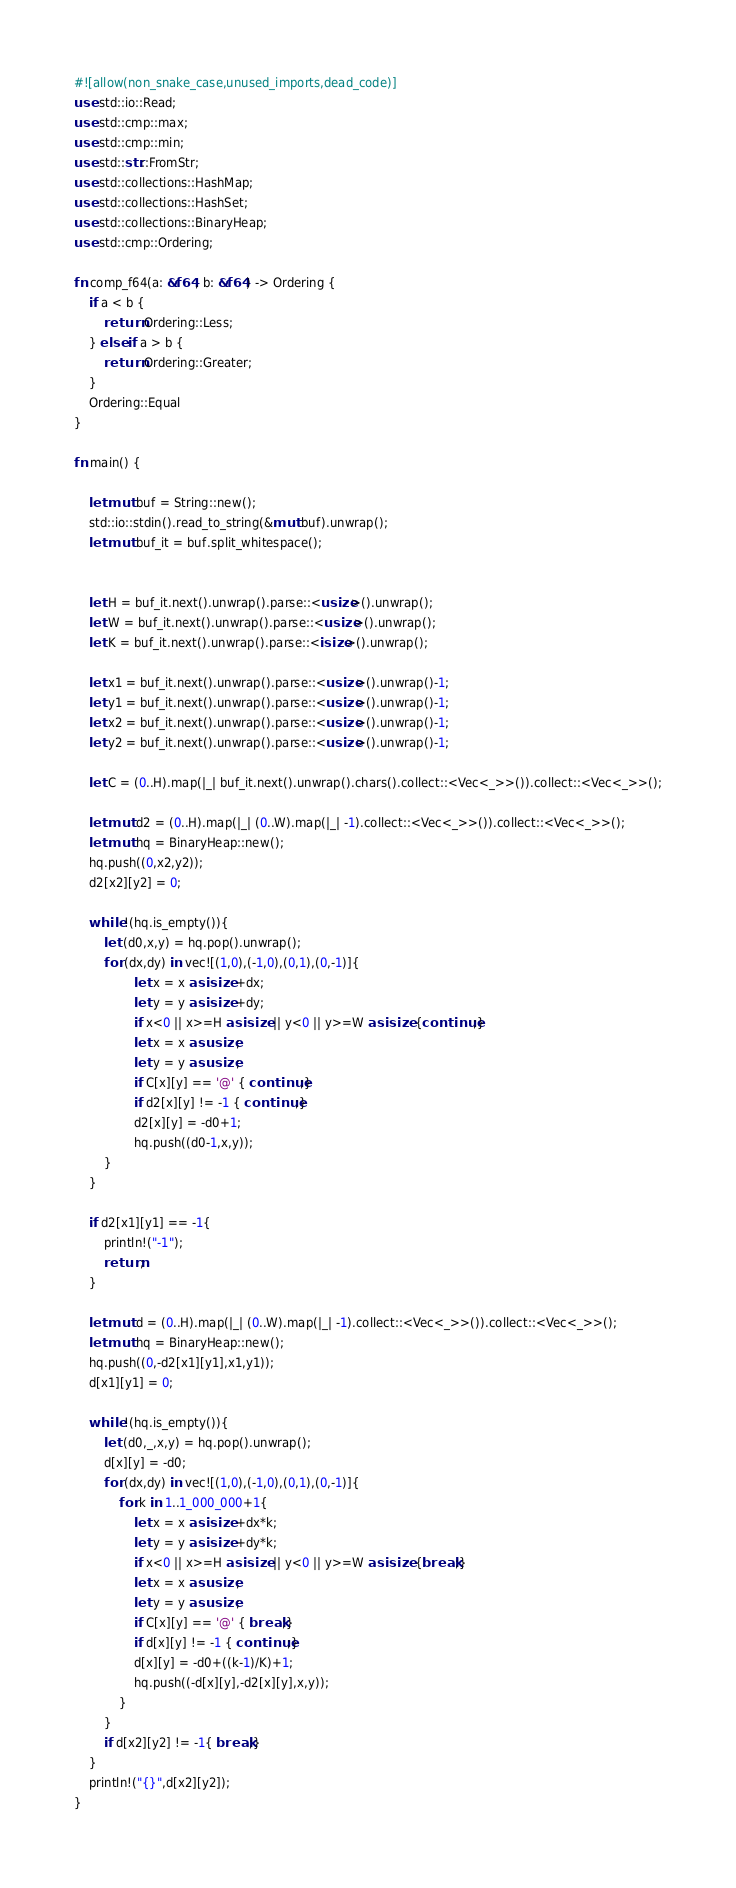Convert code to text. <code><loc_0><loc_0><loc_500><loc_500><_Rust_>#![allow(non_snake_case,unused_imports,dead_code)]
use std::io::Read;
use std::cmp::max;
use std::cmp::min;
use std::str::FromStr;
use std::collections::HashMap;
use std::collections::HashSet;
use std::collections::BinaryHeap;
use std::cmp::Ordering;

fn comp_f64(a: &f64, b: &f64) -> Ordering {
    if a < b {
        return Ordering::Less;
    } else if a > b {
        return Ordering::Greater;
    }
    Ordering::Equal
}

fn main() {

    let mut buf = String::new();
    std::io::stdin().read_to_string(&mut buf).unwrap();
    let mut buf_it = buf.split_whitespace();


    let H = buf_it.next().unwrap().parse::<usize>().unwrap();
    let W = buf_it.next().unwrap().parse::<usize>().unwrap();
    let K = buf_it.next().unwrap().parse::<isize>().unwrap();
    
    let x1 = buf_it.next().unwrap().parse::<usize>().unwrap()-1;
    let y1 = buf_it.next().unwrap().parse::<usize>().unwrap()-1;
    let x2 = buf_it.next().unwrap().parse::<usize>().unwrap()-1;
    let y2 = buf_it.next().unwrap().parse::<usize>().unwrap()-1;

    let C = (0..H).map(|_| buf_it.next().unwrap().chars().collect::<Vec<_>>()).collect::<Vec<_>>();

    let mut d2 = (0..H).map(|_| (0..W).map(|_| -1).collect::<Vec<_>>()).collect::<Vec<_>>();
    let mut hq = BinaryHeap::new();
    hq.push((0,x2,y2));
    d2[x2][y2] = 0;

    while !(hq.is_empty()){
        let (d0,x,y) = hq.pop().unwrap();
        for (dx,dy) in vec![(1,0),(-1,0),(0,1),(0,-1)]{
                let x = x as isize +dx;
                let y = y as isize +dy;
                if x<0 || x>=H as isize || y<0 || y>=W as isize {continue;}
                let x = x as usize;
                let y = y as usize;
                if C[x][y] == '@' { continue;}
                if d2[x][y] != -1 { continue;}
                d2[x][y] = -d0+1;
                hq.push((d0-1,x,y));
        }
    }

    if d2[x1][y1] == -1{
        println!("-1");
        return;
    }

    let mut d = (0..H).map(|_| (0..W).map(|_| -1).collect::<Vec<_>>()).collect::<Vec<_>>();
    let mut hq = BinaryHeap::new();
    hq.push((0,-d2[x1][y1],x1,y1));
    d[x1][y1] = 0;

    while !(hq.is_empty()){
        let (d0,_,x,y) = hq.pop().unwrap();
        d[x][y] = -d0;
        for (dx,dy) in vec![(1,0),(-1,0),(0,1),(0,-1)]{
            for k in 1..1_000_000+1{
                let x = x as isize +dx*k;
                let y = y as isize +dy*k;
                if x<0 || x>=H as isize || y<0 || y>=W as isize {break;}
                let x = x as usize;
                let y = y as usize;
                if C[x][y] == '@' { break;}
                if d[x][y] != -1 { continue;}
                d[x][y] = -d0+((k-1)/K)+1;
                hq.push((-d[x][y],-d2[x][y],x,y));
            }
        }
        if d[x2][y2] != -1{ break;}
    }
    println!("{}",d[x2][y2]);
}
</code> 